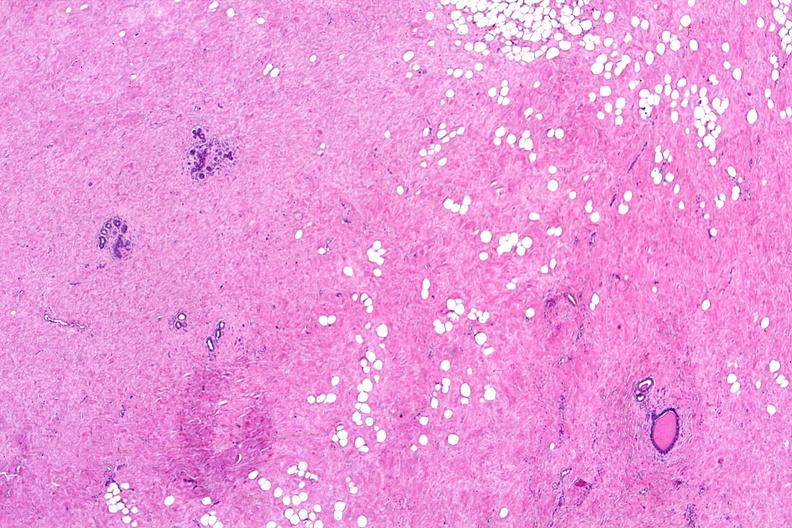what does this image show?
Answer the question using a single word or phrase. Normal breast 